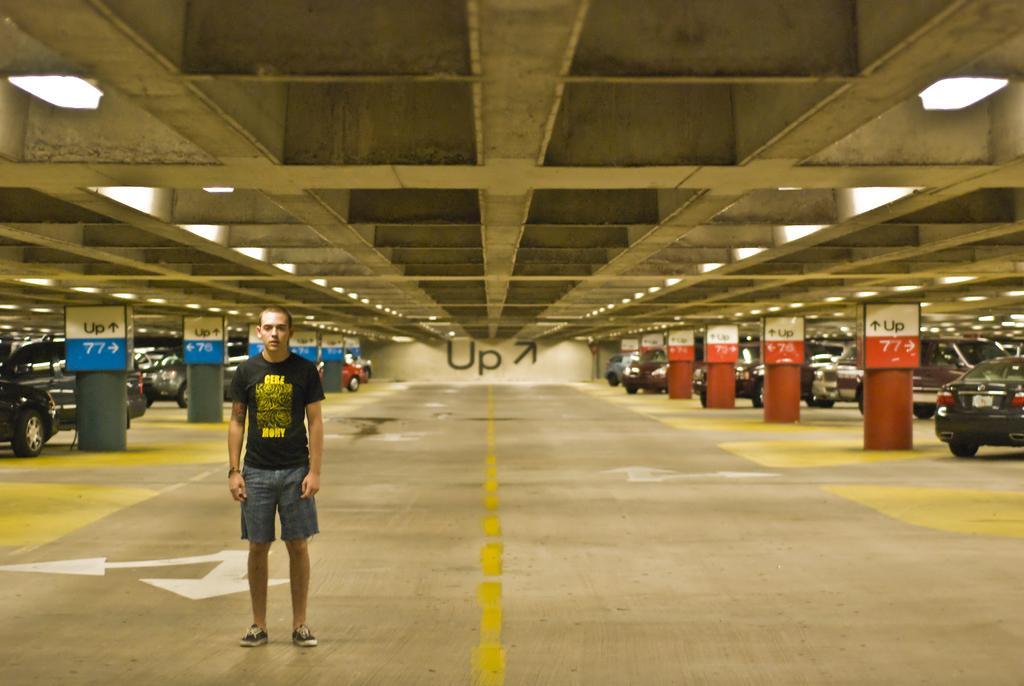Could you give a brief overview of what you see in this image? In this image we can see a person standing. Behind the person we can see the pillars, vehicles and a wall. On the wall we can see some text. At the top we can see a roof and lights. 